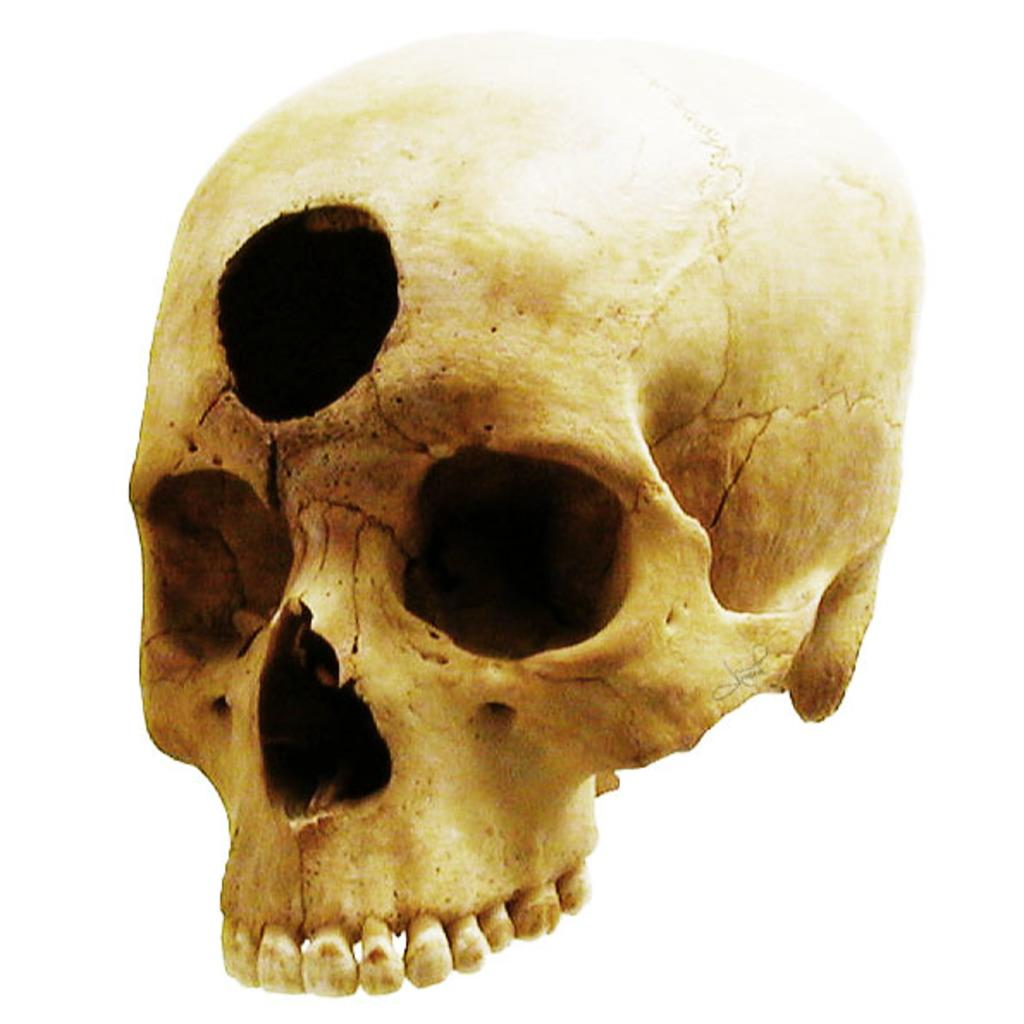What is the main subject of the image? The main subject of the image is a bone face skull. Can you describe any specific features of the skull? Yes, there is a hole in between the forehead of the skull in the image. What is the tendency of the copper waste in the image? There is no copper waste present in the image. 